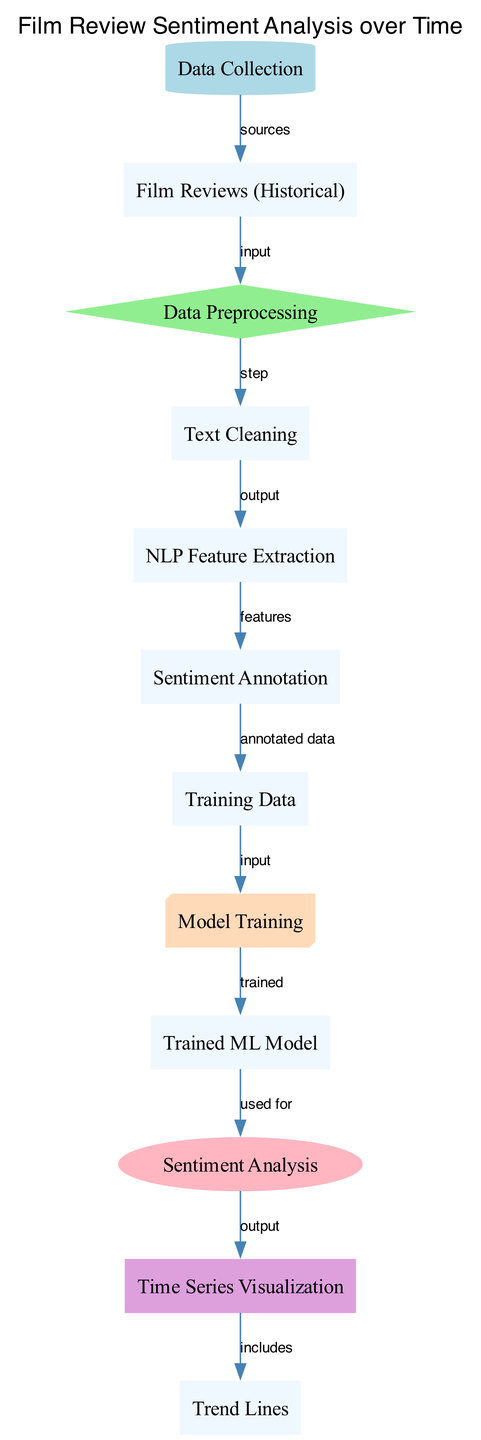What are the sources of data collection? The diagram shows a directed edge from "Data Collection" to "Film Reviews (Historical)", indicating that the film reviews serve as the data sources for the initial step of data collection.
Answer: Film Reviews (Historical) What is the output of the preprocessing step? According to the diagram, the output of the "Data Preprocessing" step is connected to "Text Cleaning", indicating that after preprocessing, the next step involves cleaning the text data.
Answer: Text Cleaning How many edges are there in the diagram? By counting the connections outlined in the diagram, there are a total of 10 directed edges linking various nodes.
Answer: 10 What does the trained ML model utilize next? The diagram indicates that the "Trained ML Model" is used for "Sentiment Analysis", making that the direct output from the trained model.
Answer: Sentiment Analysis What is included in the time series visualization? The directed edge from "Time Series Visualization" to "Trend Lines" denotes that the trend lines are a component of the visualization produced at this step.
Answer: Trend Lines What is the purpose of sentiment annotation? The "Sentiment Annotation" node is connected to "Training Data" in the diagram, revealing that the sentiment annotation serves the purpose of generating annotated data needed for training.
Answer: Annotated data What is the first step in the process? The diagram begins with "Data Collection" as the first node, which signifies the starting point of the sentiment analysis process.
Answer: Data Collection Which step follows text cleaning? The diagram shows that after "Text Cleaning", the next step is "NLP Feature Extraction", indicating the sequential flow of the process.
Answer: NLP Feature Extraction What does the sentiment analysis produce? The output of the "Sentiment Analysis" node connects to "Time Series Visualization", signifying that the analysis provides data for visualizing sentiment trends over time.
Answer: Time Series Visualization 